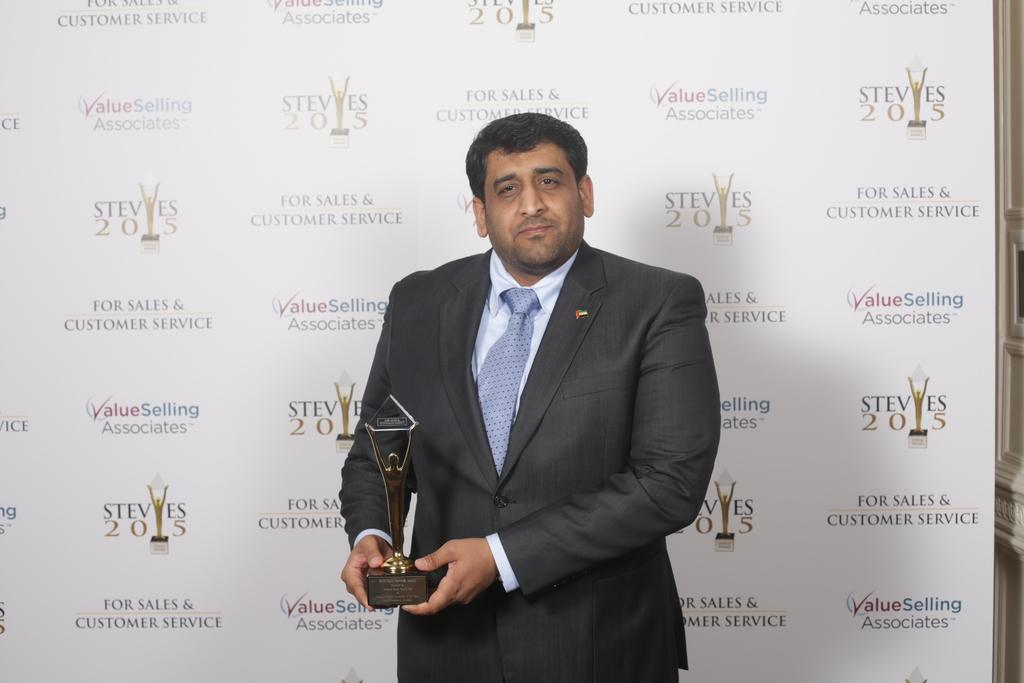Who is present in the image? There is a man in the image. What is the man wearing? The man is wearing a blazer and a tie. What is the man holding in the image? The man is holding a trophy. What else can be seen in the image? There is a banner visible in the image. Are there any icicles hanging from the man's tail in the image? There is no man with a tail present in the image, and therefore no icicles can be observed hanging from it. 